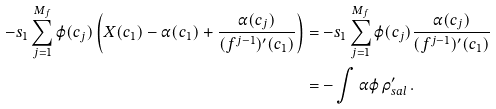<formula> <loc_0><loc_0><loc_500><loc_500>- s _ { 1 } \sum _ { j = 1 } ^ { M _ { f } } \varphi ( c _ { j } ) \left ( X ( c _ { 1 } ) - \alpha ( c _ { 1 } ) + \frac { \alpha ( c _ { j } ) } { ( f ^ { j - 1 } ) ^ { \prime } ( c _ { 1 } ) } \right ) & = - s _ { 1 } \sum _ { j = 1 } ^ { M _ { f } } \varphi ( c _ { j } ) \frac { \alpha ( c _ { j } ) } { ( f ^ { j - 1 } ) ^ { \prime } ( c _ { 1 } ) } \\ & = - \int \alpha \varphi \, \rho ^ { \prime } _ { s a l } \, .</formula> 